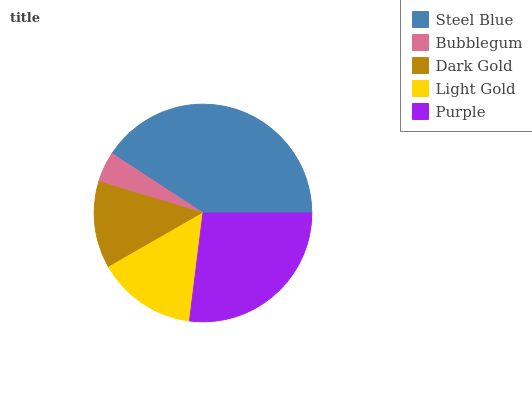Is Bubblegum the minimum?
Answer yes or no. Yes. Is Steel Blue the maximum?
Answer yes or no. Yes. Is Dark Gold the minimum?
Answer yes or no. No. Is Dark Gold the maximum?
Answer yes or no. No. Is Dark Gold greater than Bubblegum?
Answer yes or no. Yes. Is Bubblegum less than Dark Gold?
Answer yes or no. Yes. Is Bubblegum greater than Dark Gold?
Answer yes or no. No. Is Dark Gold less than Bubblegum?
Answer yes or no. No. Is Light Gold the high median?
Answer yes or no. Yes. Is Light Gold the low median?
Answer yes or no. Yes. Is Dark Gold the high median?
Answer yes or no. No. Is Steel Blue the low median?
Answer yes or no. No. 